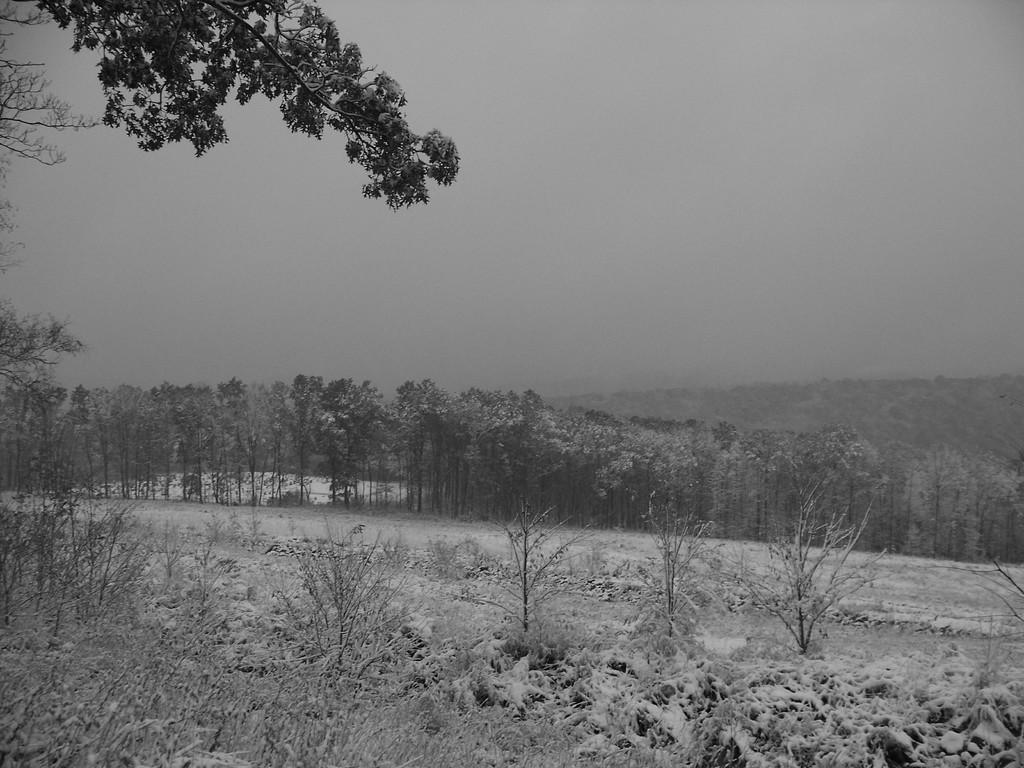What is the color scheme of the image? The image is black and white. What can be seen in the middle of the image? There are many trees in the middle of the image. What is visible at the top of the image? The sky is visible at the top of the image. What type of vegetation is present on the left side of the image? Green leaves are present on the left side of the image. What time of day is suggested by the angle of the sun in the image? There is no angle of the sun in the image, as it is a black and white image without any visible celestial bodies. 